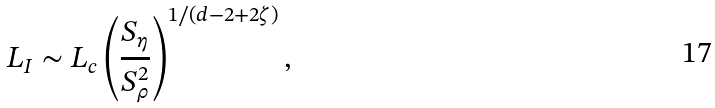Convert formula to latex. <formula><loc_0><loc_0><loc_500><loc_500>L _ { I } \sim L _ { c } \left ( \frac { S _ { \eta } } { S ^ { 2 } _ { \rho } } \right ) ^ { 1 / ( d - 2 + 2 \zeta ) } ,</formula> 